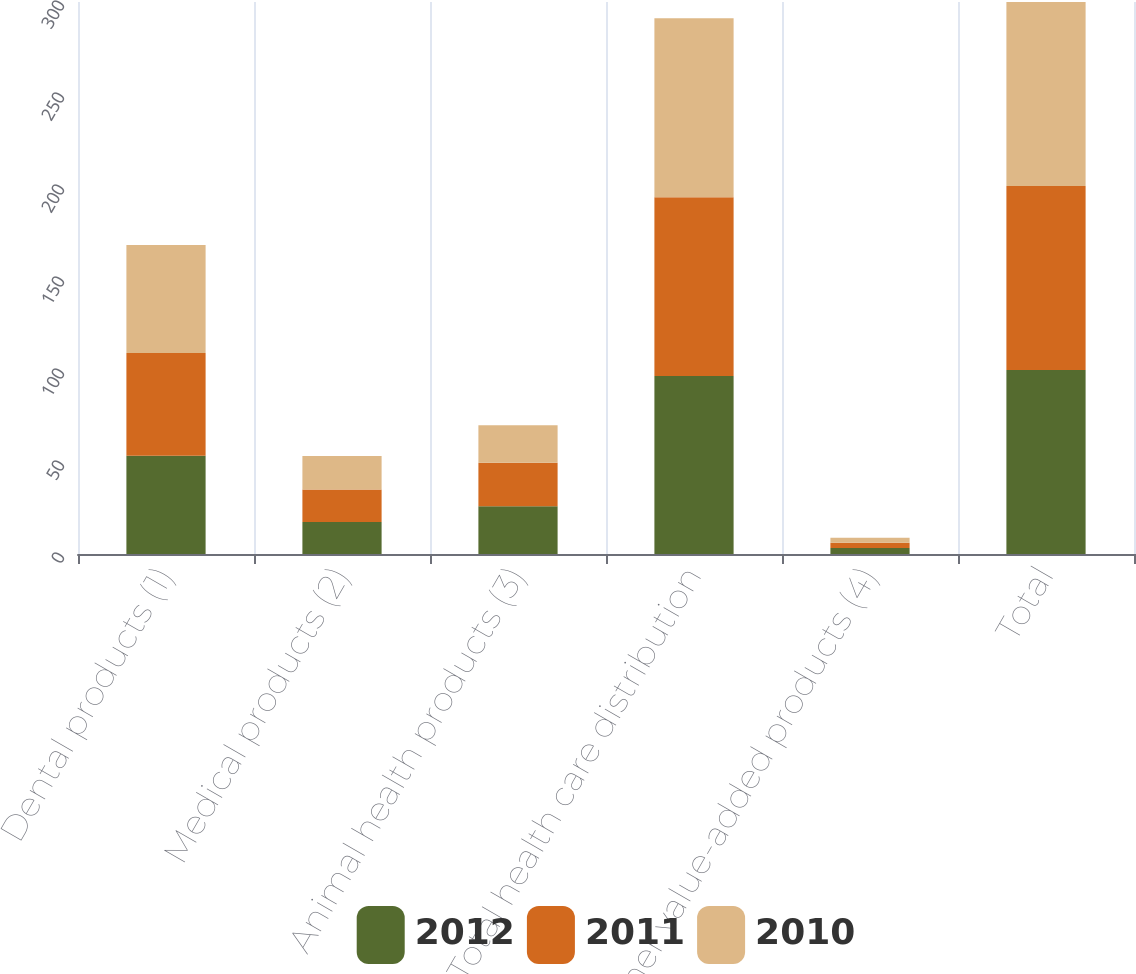Convert chart to OTSL. <chart><loc_0><loc_0><loc_500><loc_500><stacked_bar_chart><ecel><fcel>Dental products (1)<fcel>Medical products (2)<fcel>Animal health products (3)<fcel>Total health care distribution<fcel>other value-added products (4)<fcel>Total<nl><fcel>2012<fcel>53.4<fcel>17.4<fcel>26<fcel>96.8<fcel>3.2<fcel>100<nl><fcel>2011<fcel>55.9<fcel>17.6<fcel>23.6<fcel>97.1<fcel>2.9<fcel>100<nl><fcel>2010<fcel>58.7<fcel>18.2<fcel>20.4<fcel>97.3<fcel>2.7<fcel>100<nl></chart> 